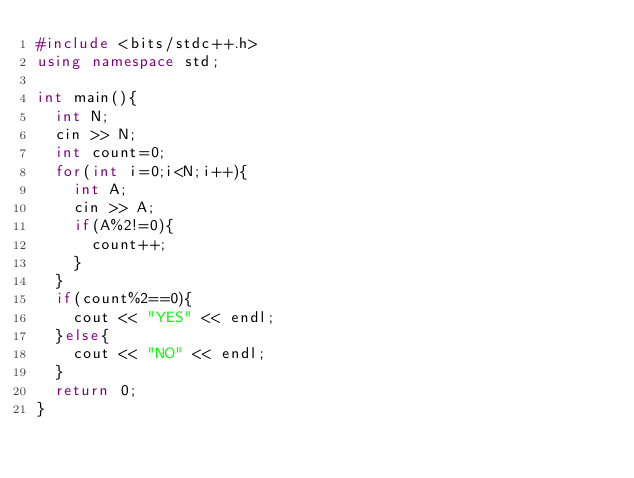Convert code to text. <code><loc_0><loc_0><loc_500><loc_500><_C++_>#include <bits/stdc++.h>
using namespace std;

int main(){
  int N;
  cin >> N;
  int count=0;
  for(int i=0;i<N;i++){
    int A;
    cin >> A;
    if(A%2!=0){
      count++;
    }
  }
  if(count%2==0){
    cout << "YES" << endl;
  }else{
    cout << "NO" << endl;
  }
  return 0;
}
</code> 